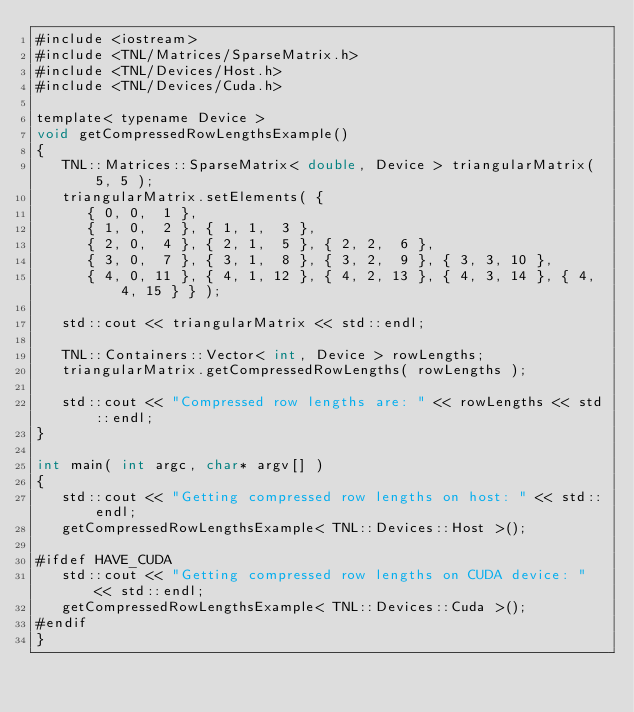<code> <loc_0><loc_0><loc_500><loc_500><_Cuda_>#include <iostream>
#include <TNL/Matrices/SparseMatrix.h>
#include <TNL/Devices/Host.h>
#include <TNL/Devices/Cuda.h>

template< typename Device >
void getCompressedRowLengthsExample()
{
   TNL::Matrices::SparseMatrix< double, Device > triangularMatrix( 5, 5 );
   triangularMatrix.setElements( {
      { 0, 0,  1 },
      { 1, 0,  2 }, { 1, 1,  3 },
      { 2, 0,  4 }, { 2, 1,  5 }, { 2, 2,  6 },
      { 3, 0,  7 }, { 3, 1,  8 }, { 3, 2,  9 }, { 3, 3, 10 },
      { 4, 0, 11 }, { 4, 1, 12 }, { 4, 2, 13 }, { 4, 3, 14 }, { 4, 4, 15 } } );

   std::cout << triangularMatrix << std::endl;

   TNL::Containers::Vector< int, Device > rowLengths;
   triangularMatrix.getCompressedRowLengths( rowLengths );

   std::cout << "Compressed row lengths are: " << rowLengths << std::endl;
}

int main( int argc, char* argv[] )
{
   std::cout << "Getting compressed row lengths on host: " << std::endl;
   getCompressedRowLengthsExample< TNL::Devices::Host >();

#ifdef HAVE_CUDA
   std::cout << "Getting compressed row lengths on CUDA device: " << std::endl;
   getCompressedRowLengthsExample< TNL::Devices::Cuda >();
#endif
}
</code> 